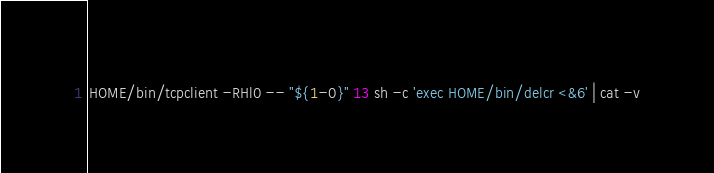Convert code to text. <code><loc_0><loc_0><loc_500><loc_500><_Bash_>HOME/bin/tcpclient -RHl0 -- "${1-0}" 13 sh -c 'exec HOME/bin/delcr <&6' | cat -v
</code> 